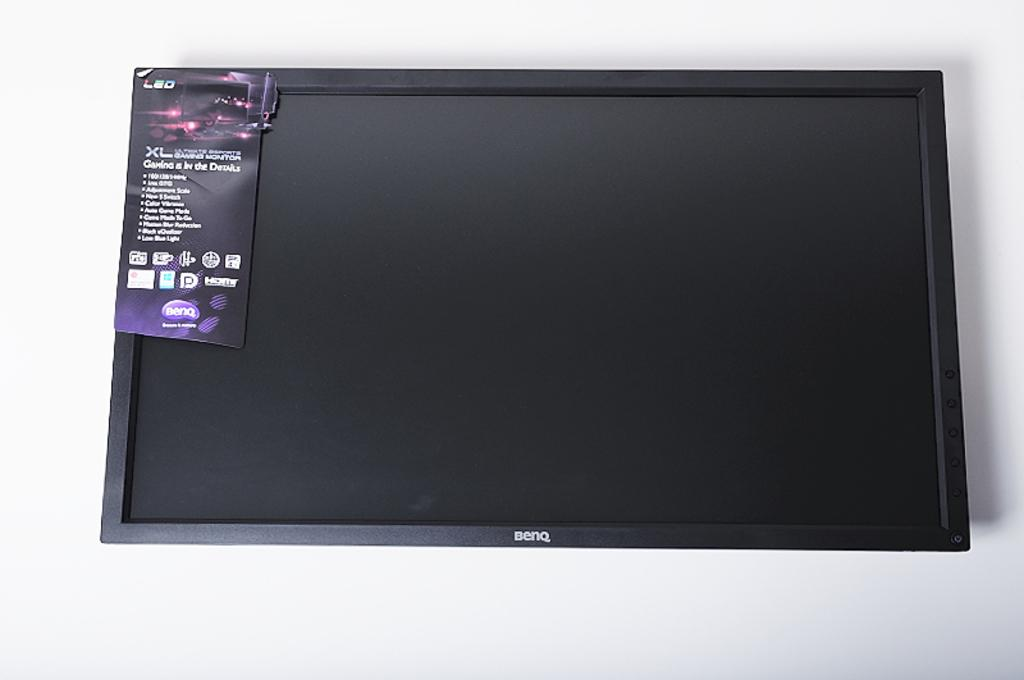<image>
Present a compact description of the photo's key features. A black monitor that says BenQ is on a white background. 